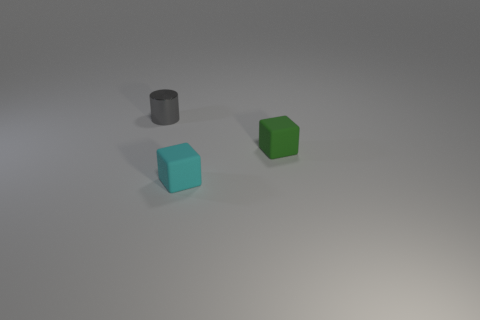Subtract all cyan cubes. How many cubes are left? 1 Subtract 1 cylinders. How many cylinders are left? 0 Add 2 small cyan matte things. How many objects exist? 5 Subtract all cubes. How many objects are left? 1 Add 1 large metal cylinders. How many large metal cylinders exist? 1 Subtract 0 purple cylinders. How many objects are left? 3 Subtract all blue cubes. Subtract all purple spheres. How many cubes are left? 2 Subtract all green cubes. Subtract all small metal cylinders. How many objects are left? 1 Add 1 tiny cyan matte things. How many tiny cyan matte things are left? 2 